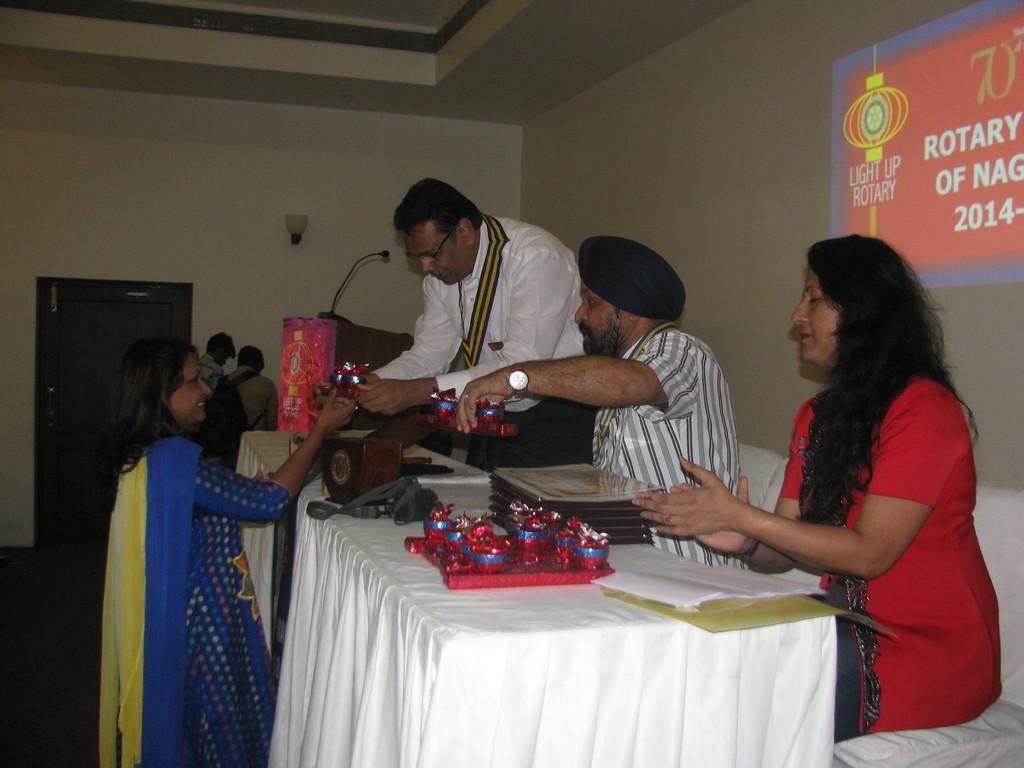Could you give a brief overview of what you see in this image? in a room there are many people in which two people are sitting and two people are standing with table in front of them 